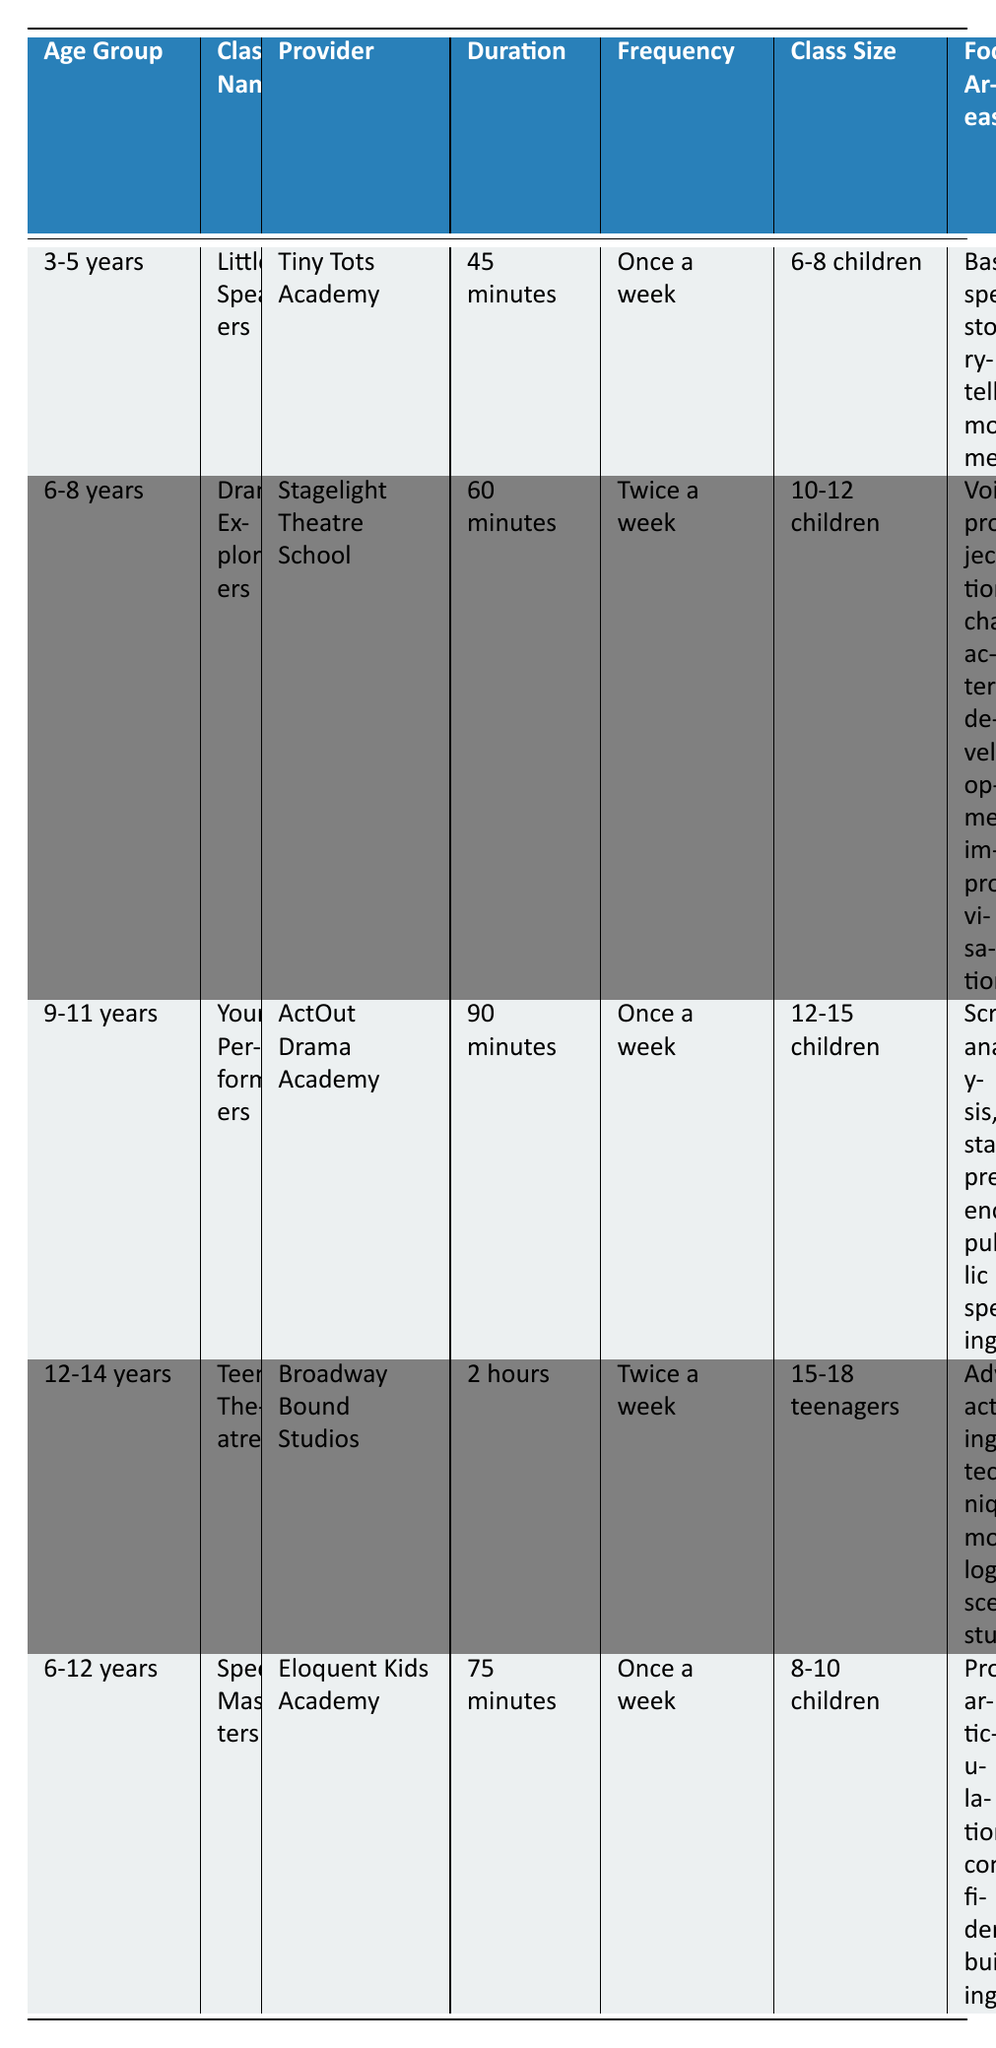What is the class size for "Young Performers"? The class size for "Young Performers" is listed in the table under the "Class Size" column. It states that there are 12-15 children in the class.
Answer: 12-15 children Which class has the longest duration? By comparing the "Duration" column, we can see that "Teen Theatre" has a duration of 2 hours, which is longer than the other classes.
Answer: Teen Theatre Is there a performance opportunity for children in the 3-5 years age group? According to the "Performance Opportunities" column, the "Little Speakers" class for the 3-5 years age group includes an end-of-term showcase, which indicates that there is a performance opportunity.
Answer: Yes What is the average cost per month of classes for the 6-8 years age group? The classes for the 6-8 years age group are "Drama Explorers" ($120) and "Speech Masters" ($100). To find the average, we sum the costs ($120 + $100 = $220) and divide by the number of classes (2), which gives us an average cost of $110 per month.
Answer: $110 Does the "Speech Masters" class focus on acting techniques? The "Focus Areas" for "Speech Masters" include pronunciation, articulation, and confidence building, but do not mention acting techniques. Therefore, the answer is no.
Answer: No Which age group has the highest cost for classes, and what is that cost? By examining the "Cost (per month)" column, "Teen Theatre" has the highest cost at $200. Therefore, the age group of 12-14 years has the highest cost.
Answer: 12-14 years, $200 What is the total number of children in the "Drama Explorers" class? The "Drama Explorers" class has a class size of 10-12 children, which indicates that the total can range from 10 to 12, but does not provide a specific total. So, the answer reflects the given range.
Answer: 10-12 children Are there any classes that occur twice a week? By looking at the "Frequency" column, both "Drama Explorers" and "Teen Theatre" are noted as occurring twice a week, confirming that there are classes with that frequency.
Answer: Yes 